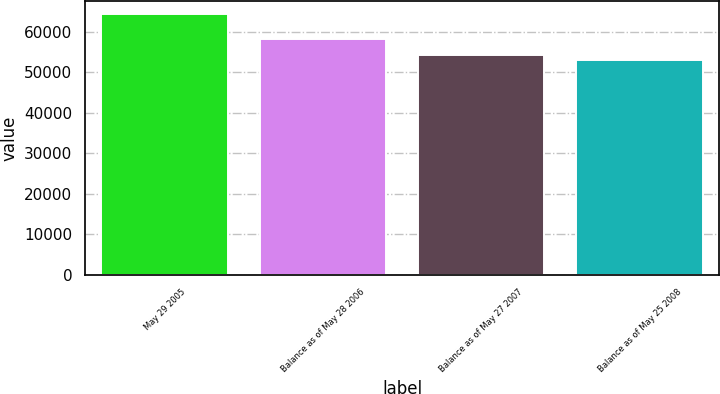Convert chart. <chart><loc_0><loc_0><loc_500><loc_500><bar_chart><fcel>May 29 2005<fcel>Balance as of May 28 2006<fcel>Balance as of May 27 2007<fcel>Balance as of May 25 2008<nl><fcel>64259.4<fcel>58203.1<fcel>54145<fcel>53021.2<nl></chart> 